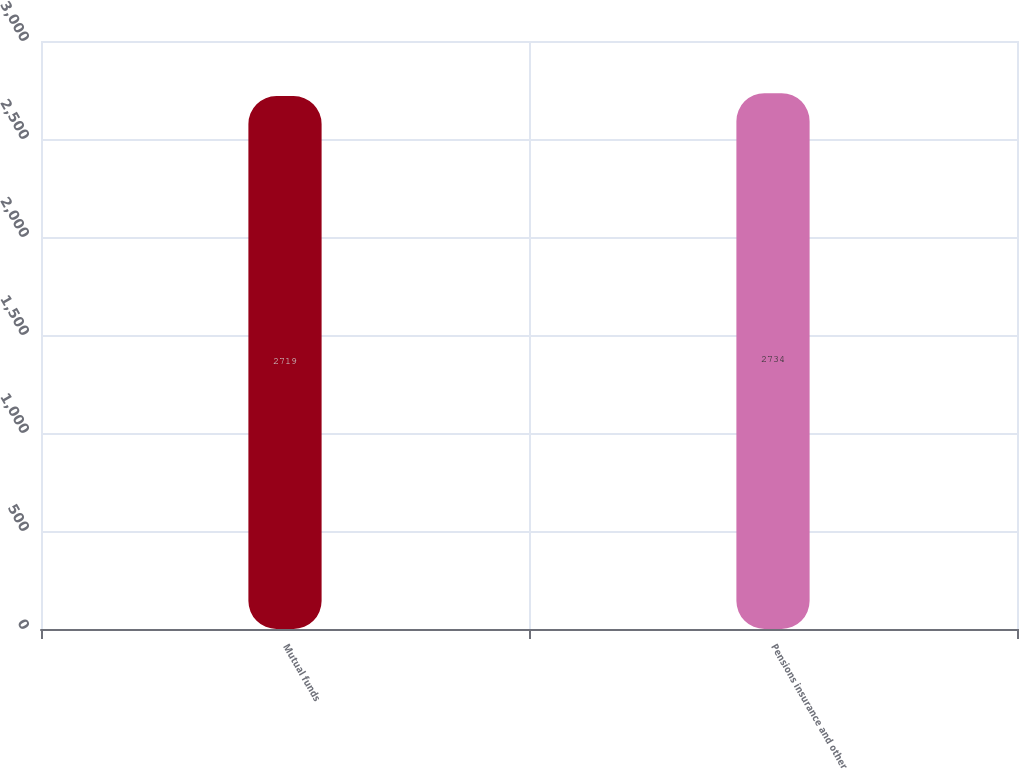Convert chart to OTSL. <chart><loc_0><loc_0><loc_500><loc_500><bar_chart><fcel>Mutual funds<fcel>Pensions insurance and other<nl><fcel>2719<fcel>2734<nl></chart> 